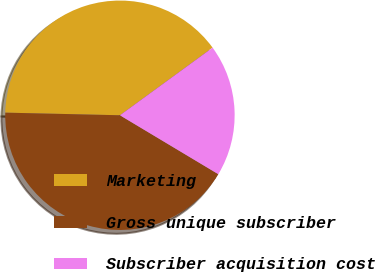Convert chart to OTSL. <chart><loc_0><loc_0><loc_500><loc_500><pie_chart><fcel>Marketing<fcel>Gross unique subscriber<fcel>Subscriber acquisition cost<nl><fcel>39.6%<fcel>41.77%<fcel>18.62%<nl></chart> 